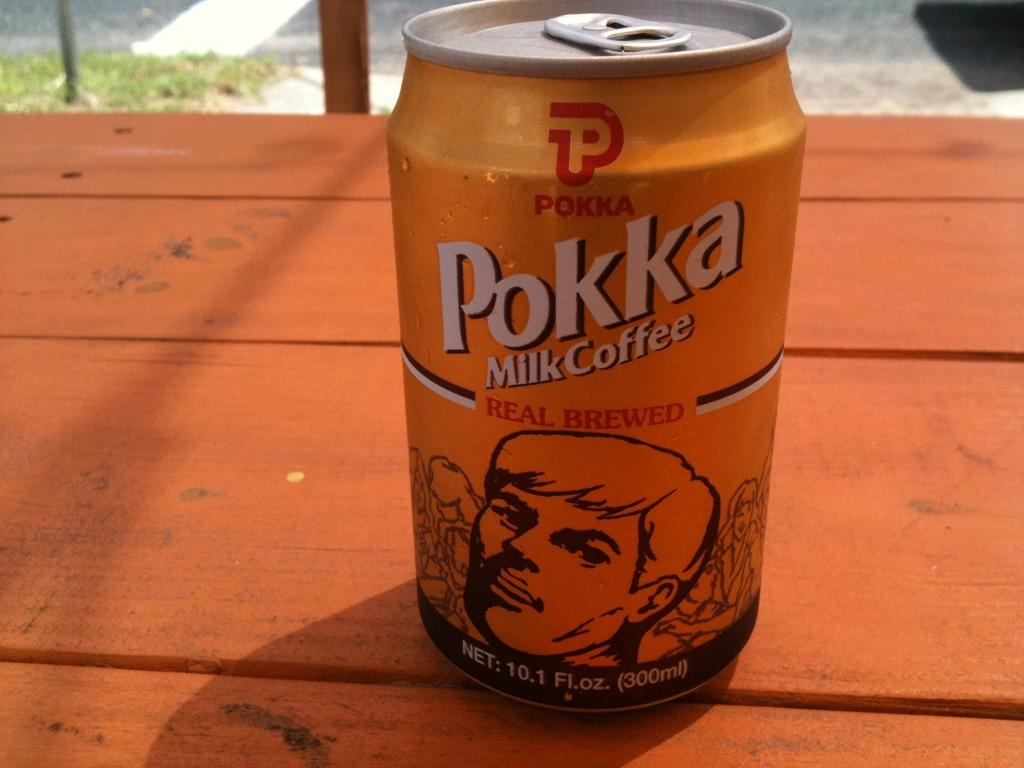<image>
Describe the image concisely. A yellow and brown can of milk coffee with a red logo that says Pokka. 